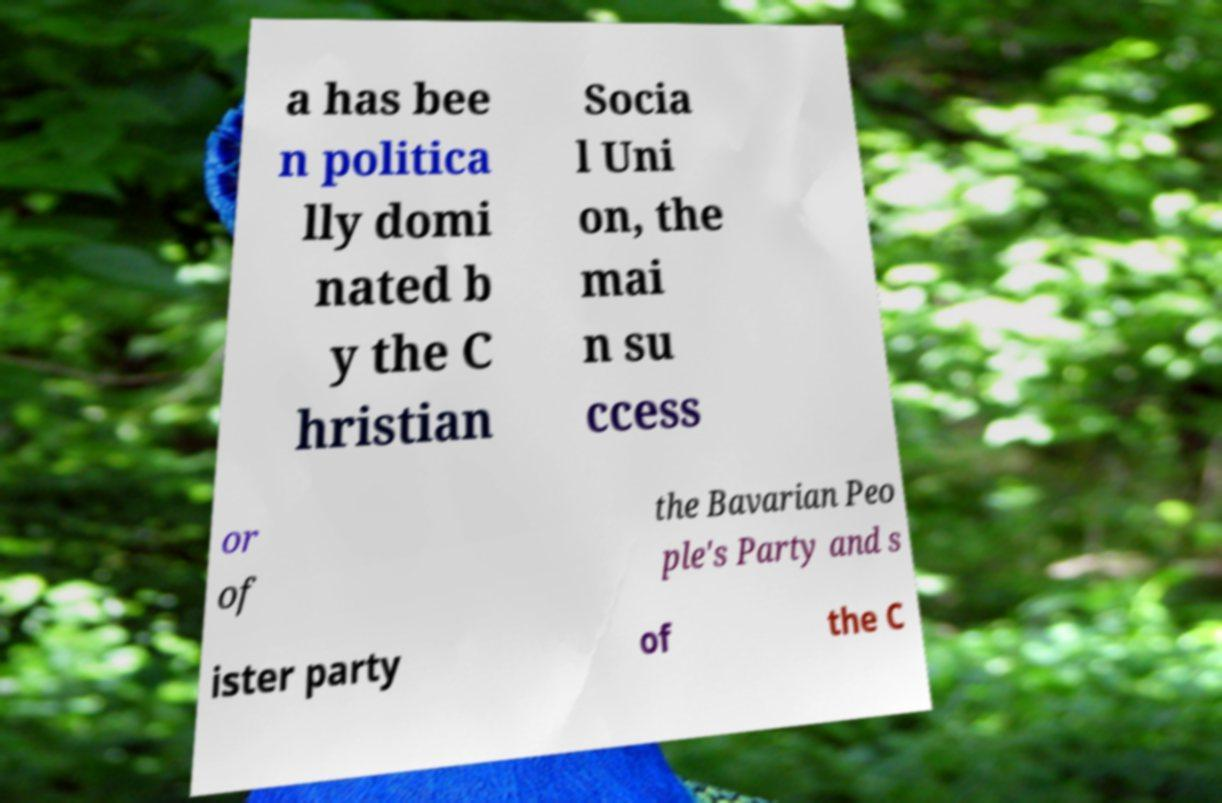What messages or text are displayed in this image? I need them in a readable, typed format. a has bee n politica lly domi nated b y the C hristian Socia l Uni on, the mai n su ccess or of the Bavarian Peo ple's Party and s ister party of the C 